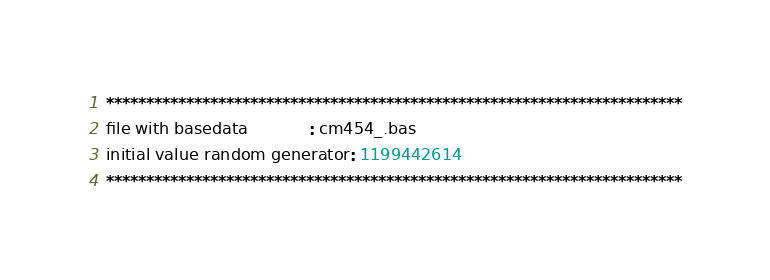Convert code to text. <code><loc_0><loc_0><loc_500><loc_500><_ObjectiveC_>************************************************************************
file with basedata            : cm454_.bas
initial value random generator: 1199442614
************************************************************************</code> 